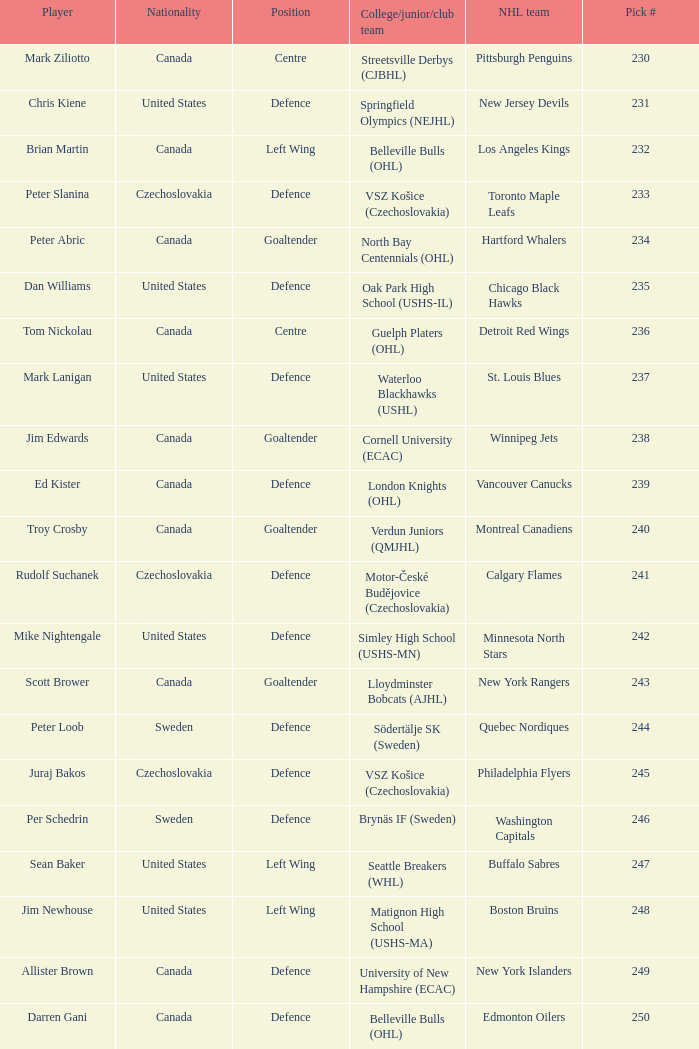What position does allister brown play. Defence. Can you give me this table as a dict? {'header': ['Player', 'Nationality', 'Position', 'College/junior/club team', 'NHL team', 'Pick #'], 'rows': [['Mark Ziliotto', 'Canada', 'Centre', 'Streetsville Derbys (CJBHL)', 'Pittsburgh Penguins', '230'], ['Chris Kiene', 'United States', 'Defence', 'Springfield Olympics (NEJHL)', 'New Jersey Devils', '231'], ['Brian Martin', 'Canada', 'Left Wing', 'Belleville Bulls (OHL)', 'Los Angeles Kings', '232'], ['Peter Slanina', 'Czechoslovakia', 'Defence', 'VSZ Košice (Czechoslovakia)', 'Toronto Maple Leafs', '233'], ['Peter Abric', 'Canada', 'Goaltender', 'North Bay Centennials (OHL)', 'Hartford Whalers', '234'], ['Dan Williams', 'United States', 'Defence', 'Oak Park High School (USHS-IL)', 'Chicago Black Hawks', '235'], ['Tom Nickolau', 'Canada', 'Centre', 'Guelph Platers (OHL)', 'Detroit Red Wings', '236'], ['Mark Lanigan', 'United States', 'Defence', 'Waterloo Blackhawks (USHL)', 'St. Louis Blues', '237'], ['Jim Edwards', 'Canada', 'Goaltender', 'Cornell University (ECAC)', 'Winnipeg Jets', '238'], ['Ed Kister', 'Canada', 'Defence', 'London Knights (OHL)', 'Vancouver Canucks', '239'], ['Troy Crosby', 'Canada', 'Goaltender', 'Verdun Juniors (QMJHL)', 'Montreal Canadiens', '240'], ['Rudolf Suchanek', 'Czechoslovakia', 'Defence', 'Motor-České Budějovice (Czechoslovakia)', 'Calgary Flames', '241'], ['Mike Nightengale', 'United States', 'Defence', 'Simley High School (USHS-MN)', 'Minnesota North Stars', '242'], ['Scott Brower', 'Canada', 'Goaltender', 'Lloydminster Bobcats (AJHL)', 'New York Rangers', '243'], ['Peter Loob', 'Sweden', 'Defence', 'Södertälje SK (Sweden)', 'Quebec Nordiques', '244'], ['Juraj Bakos', 'Czechoslovakia', 'Defence', 'VSZ Košice (Czechoslovakia)', 'Philadelphia Flyers', '245'], ['Per Schedrin', 'Sweden', 'Defence', 'Brynäs IF (Sweden)', 'Washington Capitals', '246'], ['Sean Baker', 'United States', 'Left Wing', 'Seattle Breakers (WHL)', 'Buffalo Sabres', '247'], ['Jim Newhouse', 'United States', 'Left Wing', 'Matignon High School (USHS-MA)', 'Boston Bruins', '248'], ['Allister Brown', 'Canada', 'Defence', 'University of New Hampshire (ECAC)', 'New York Islanders', '249'], ['Darren Gani', 'Canada', 'Defence', 'Belleville Bulls (OHL)', 'Edmonton Oilers', '250']]} 